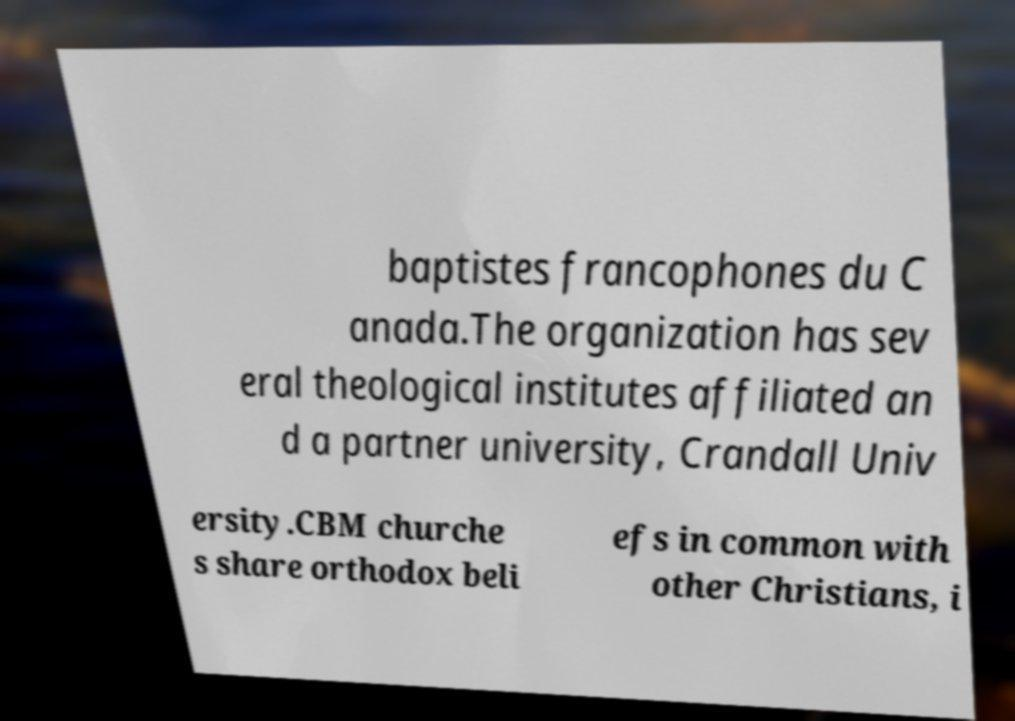Could you extract and type out the text from this image? baptistes francophones du C anada.The organization has sev eral theological institutes affiliated an d a partner university, Crandall Univ ersity.CBM churche s share orthodox beli efs in common with other Christians, i 